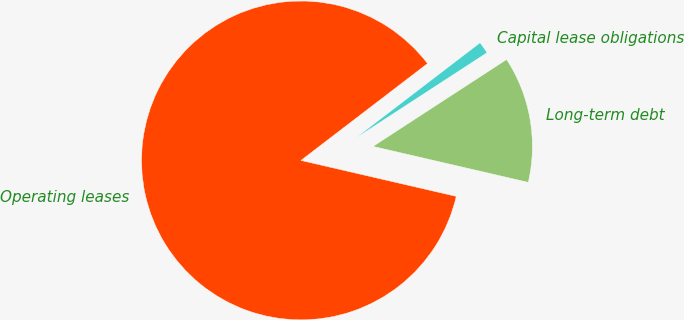Convert chart to OTSL. <chart><loc_0><loc_0><loc_500><loc_500><pie_chart><fcel>Long-term debt<fcel>Capital lease obligations<fcel>Operating leases<nl><fcel>12.8%<fcel>1.22%<fcel>85.98%<nl></chart> 